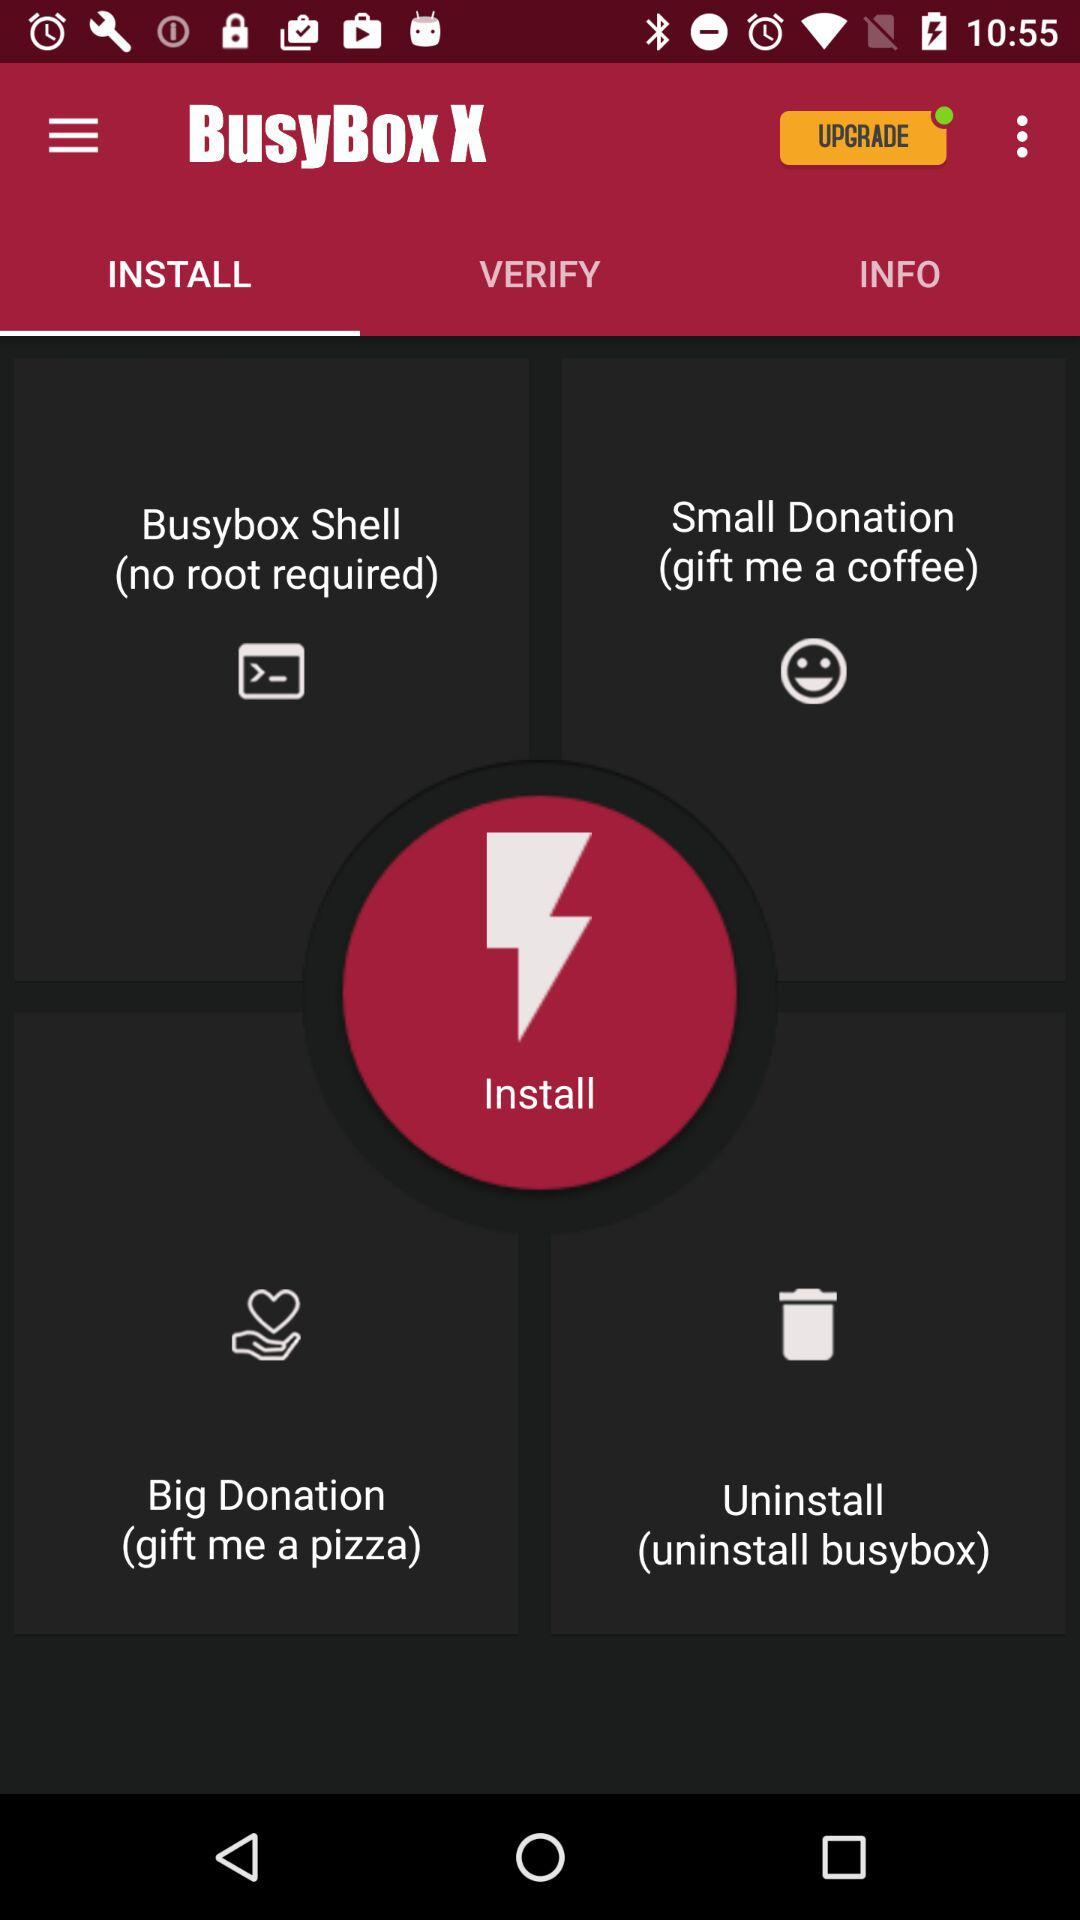Which tab of "BusyBox X" am I on? You are on the "INSTALL" tab. 